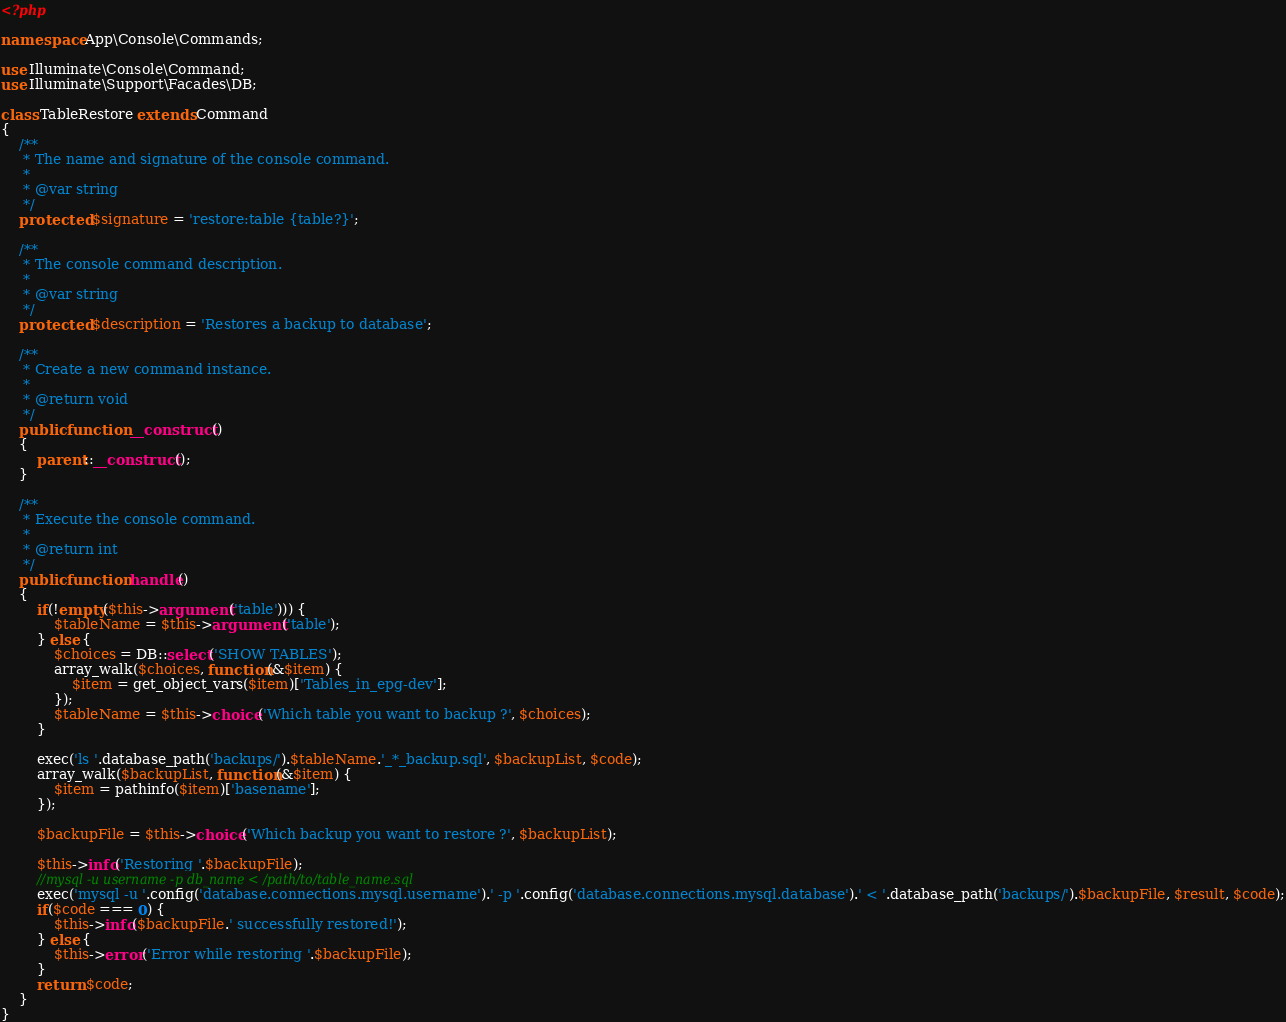<code> <loc_0><loc_0><loc_500><loc_500><_PHP_><?php

namespace App\Console\Commands;

use Illuminate\Console\Command;
use Illuminate\Support\Facades\DB;

class TableRestore extends Command
{
    /**
     * The name and signature of the console command.
     *
     * @var string
     */
    protected $signature = 'restore:table {table?}';

    /**
     * The console command description.
     *
     * @var string
     */
    protected $description = 'Restores a backup to database';

    /**
     * Create a new command instance.
     *
     * @return void
     */
    public function __construct()
    {
        parent::__construct();
    }

    /**
     * Execute the console command.
     *
     * @return int
     */
    public function handle()
    {
		if(!empty($this->argument('table'))) {
			$tableName = $this->argument('table');
		} else {
			$choices = DB::select('SHOW TABLES');
			array_walk($choices, function(&$item) {
				$item = get_object_vars($item)['Tables_in_epg-dev'];
			});
			$tableName = $this->choice('Which table you want to backup ?', $choices);
		}

		exec('ls '.database_path('backups/').$tableName.'_*_backup.sql', $backupList, $code);
		array_walk($backupList, function(&$item) {
			$item = pathinfo($item)['basename'];
		});

		$backupFile = $this->choice('Which backup you want to restore ?', $backupList);

		$this->info('Restoring '.$backupFile);
		//mysql -u username -p db_name < /path/to/table_name.sql
		exec('mysql -u '.config('database.connections.mysql.username').' -p '.config('database.connections.mysql.database').' < '.database_path('backups/').$backupFile, $result, $code);
        if($code === 0) {
			$this->info($backupFile.' successfully restored!');
		} else {
			$this->error('Error while restoring '.$backupFile);
		}
        return $code;
    }
}
</code> 